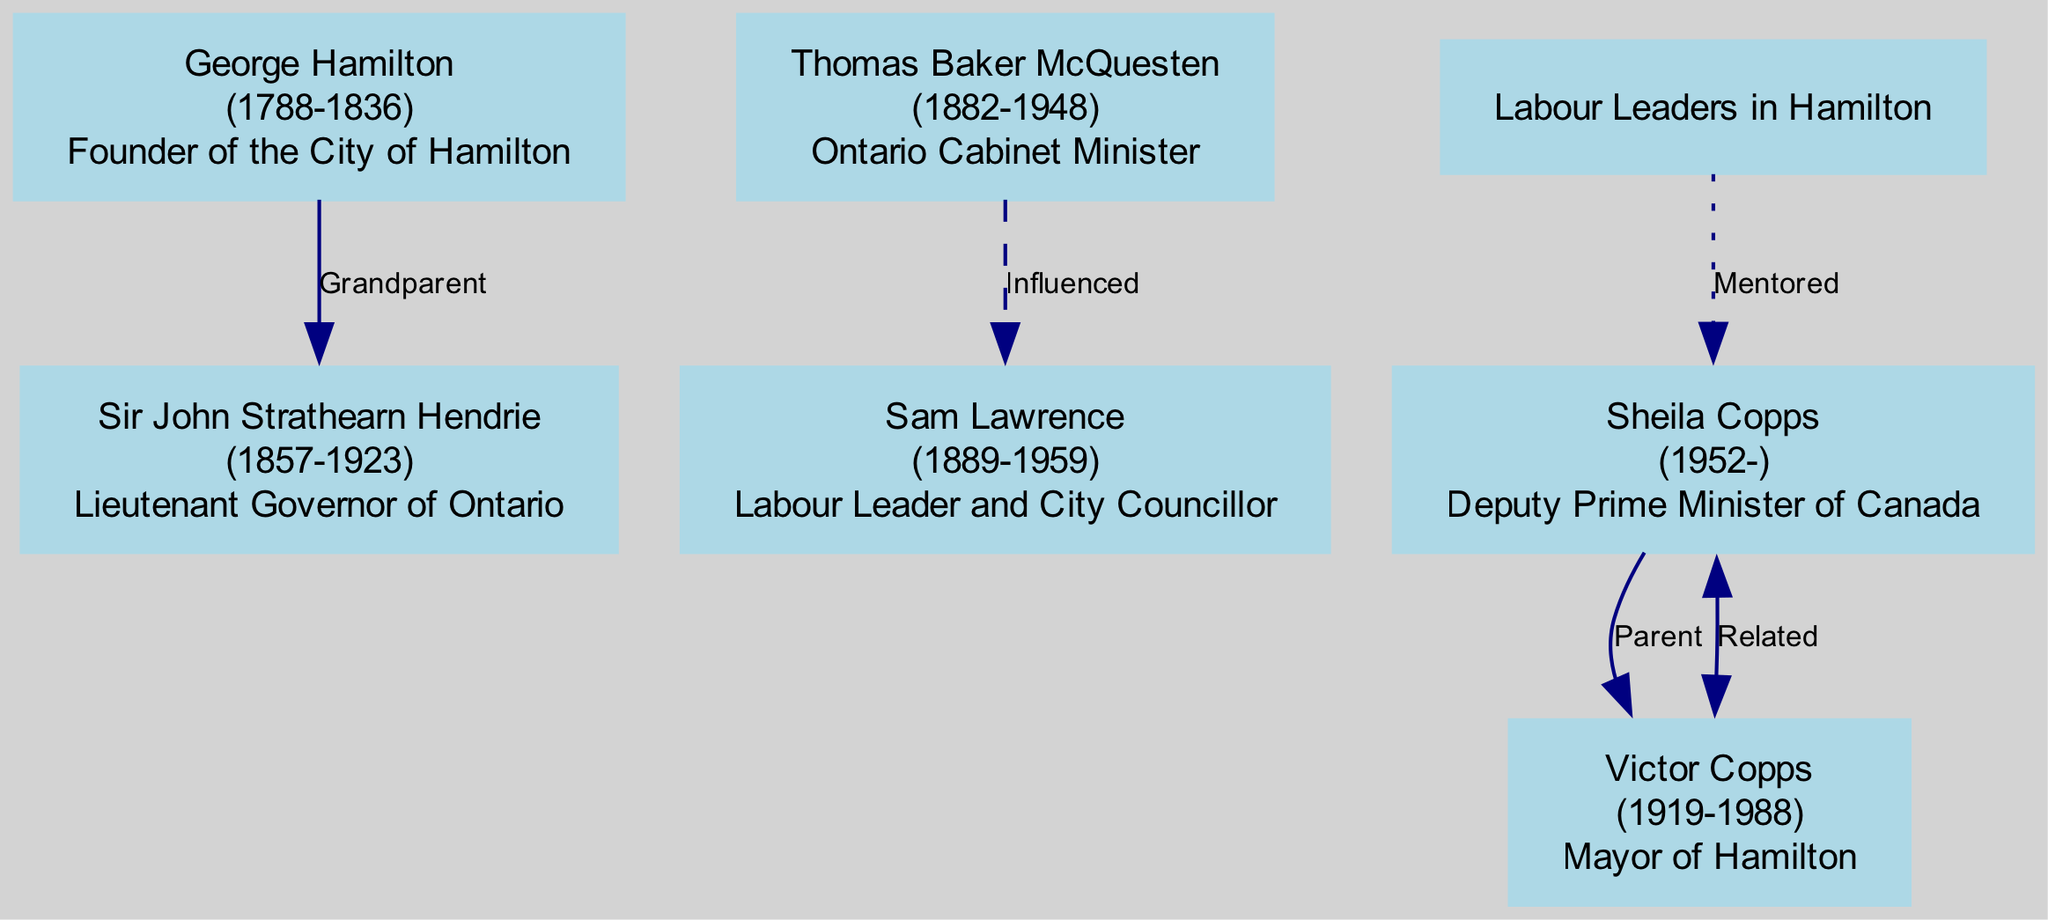What is the role of George Hamilton? The diagram shows that George Hamilton is labeled as the "Founder of the City of Hamilton." This information is directly associated with his node.
Answer: Founder of the City of Hamilton Who is the great-great grandson of George Hamilton? The diagram connects Sir John Strathearn Hendrie to George Hamilton through a "Great-Great Grandson" relationship. This connection is clearly stated in his attributes within the diagram.
Answer: Sir John Strathearn Hendrie How many individuals are influenced by Thomas Baker McQuesten? By examining the diagram, we can see that Sam Lawrence is connected to Thomas Baker McQuesten with the label "Influenced by." Therefore, only one individual is influenced by him.
Answer: 1 What role does Sheila Copps hold? The diagram identifies Sheila Copps as "Deputy Prime Minister of Canada." This designation is shown directly under her name in the diagram.
Answer: Deputy Prime Minister of Canada Which figure is the father of Sheila Copps? The diagram clearly indicates that Victor Copps is labeled as "Father of Sheila Copps,” illustrating the familial relationship.
Answer: Victor Copps How many political figures are shown in the diagram? Counting all the individuals in the diagram, we find a total of six distinct political figures listed. Therefore, the answer is based on a straightforward count of the nodes present.
Answer: 6 Who is related to Victor Copps? The diagram states that Sheila Copps is "Related to Victor Copps," showing their relationship clearly indicated around Victor's node.
Answer: Sheila Copps Which political figure serves as a Labour Leader and City Councillor? The diagram specifies that Sam Lawrence holds the position of "Labour Leader and City Councillor," providing a clear title associated with this individual.
Answer: Sam Lawrence Who mentored Sheila Copps? The diagram indicates that Sheila Copps was "Mentored by Labour Leaders in Hamilton." This is a direct connection that suggests the influence of unnamed Labour Leaders.
Answer: Labour Leaders in Hamilton 